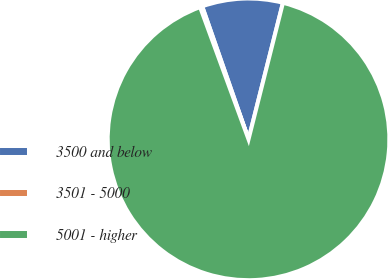<chart> <loc_0><loc_0><loc_500><loc_500><pie_chart><fcel>3500 and below<fcel>3501 - 5000<fcel>5001 - higher<nl><fcel>9.27%<fcel>0.25%<fcel>90.48%<nl></chart> 